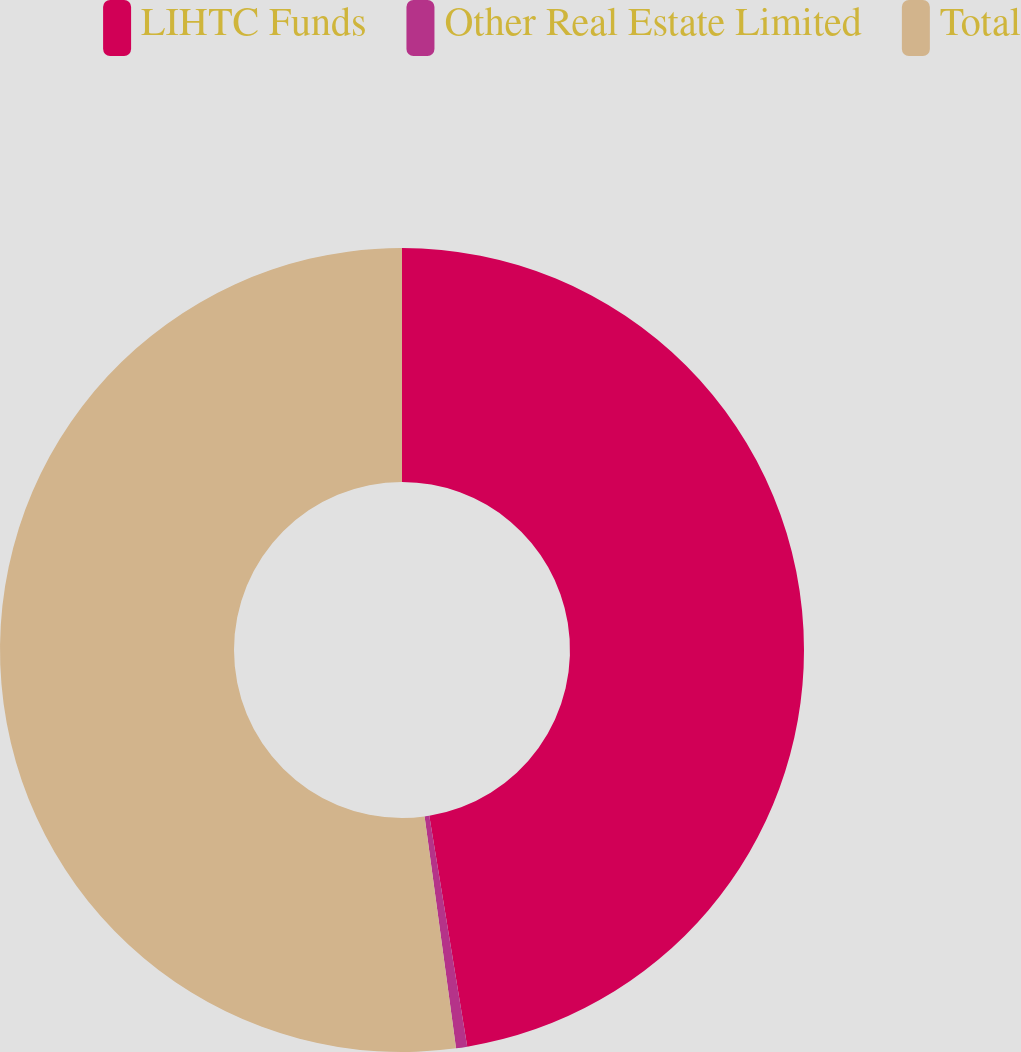<chart> <loc_0><loc_0><loc_500><loc_500><pie_chart><fcel>LIHTC Funds<fcel>Other Real Estate Limited<fcel>Total<nl><fcel>47.4%<fcel>0.45%<fcel>52.14%<nl></chart> 